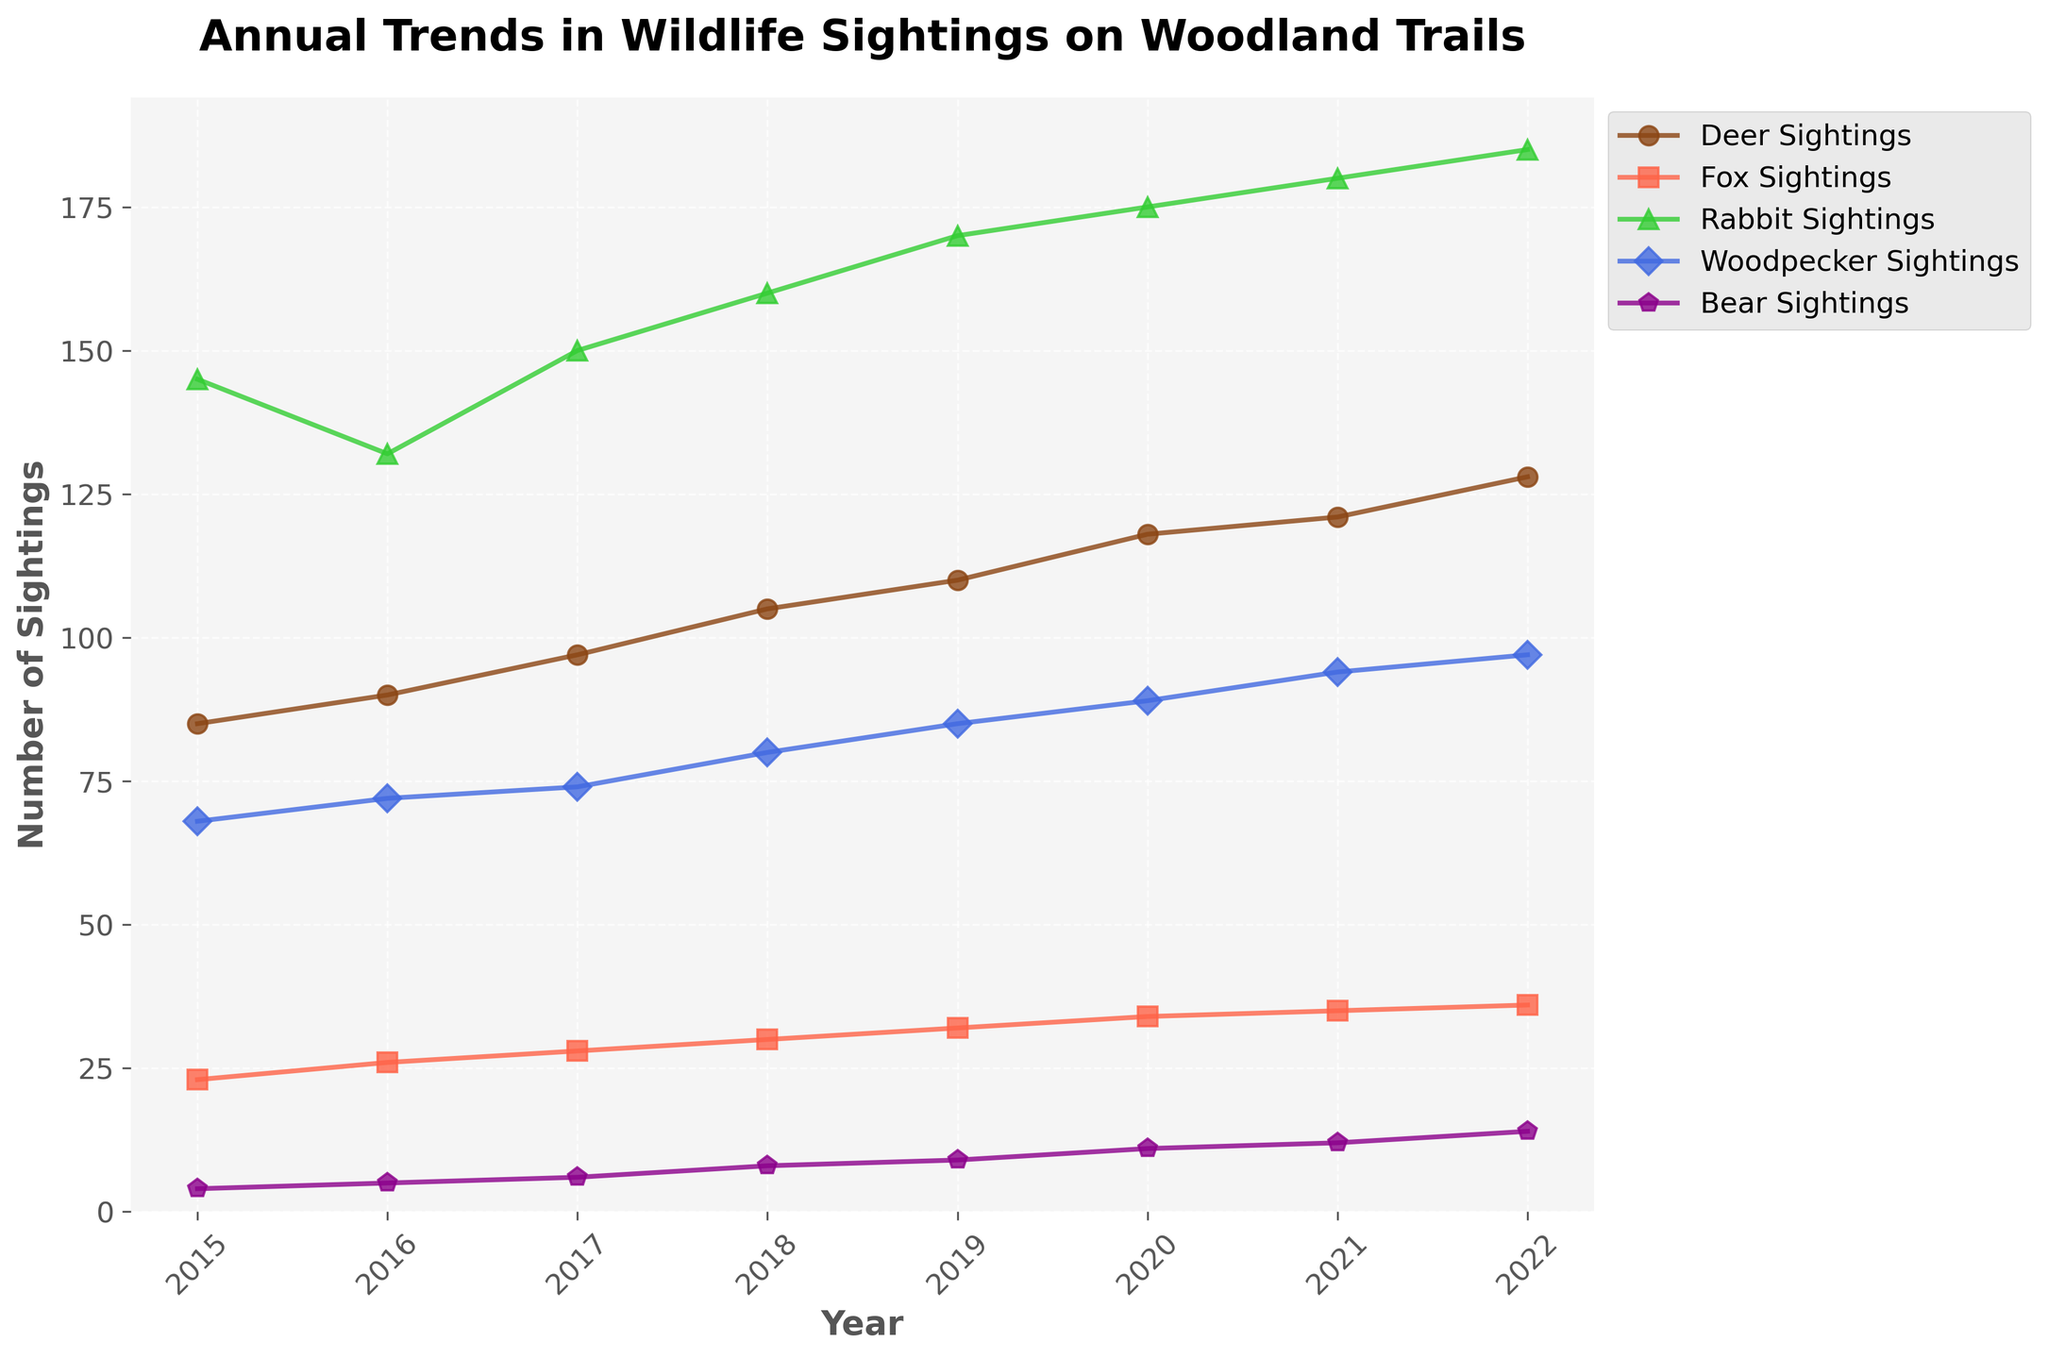what is the title of the figure? The title of the figure is prominently displayed at the top, which summarizes what the plot represents. The title specifically states the main theme of the plot.
Answer: Annual Trends in Wildlife Sightings on Woodland Trails How many different types of wildlife sightings are tracked on the plot? By visually examining the color-coded lines and the legend, we can count the number of different categories of wildlife sightings being tracked.
Answer: 5 What color represents Rabbit Sightings? The legend identifies which color corresponds to Rabbit Sightings among the other wildlife categories.
Answer: Green In which year were the most Fox Sightings reported? By looking at the trend line for Fox Sightings and identifying the highest point along the time axis (year), we can determine the year with the most sightings.
Answer: 2022 What is the overall trend in Deer Sightings from 2015 to 2022? By observing the line representing Deer Sightings over the years, we can describe the general direction or pattern. The line appears to consistently rise over the years.
Answer: Increasing How many Bear Sightings were there in 2022? By locating the data point at the intersection of 2022 on the x-axis and the Bear Sightings line, we can read off the number.
Answer: 14 Compare the number of Deer Sightings and Fox Sightings in 2018. We can compare the deer and fox sighting values for the year 2018 by looking at their respective lines and data points for that year on the x-axis.
Answer: Deer Sightings: 105, Fox Sightings: 30 What is the average number of Woodpecker Sightings over the years? To find the average, sum the Woodpecker Sightings for each year and then divide by the number of years. (68 + 72 + 74 + 80 + 85 + 89 + 94 + 97) / 8
Answer: 82.375 Which type of wildlife showed the greatest increase in sightings from 2015 to 2022? By calculating the difference in sightings between 2015 and 2022 for each type of wildlife, we can determine which saw the greatest increase.
Answer: Deer (43) Are there any years where the number of Rabbit Sightings decreased compared to the previous year? By examining the Rabbit Sightings line, we can check if there are any dips where the number in a particular year is lower than the previous year.
Answer: No 